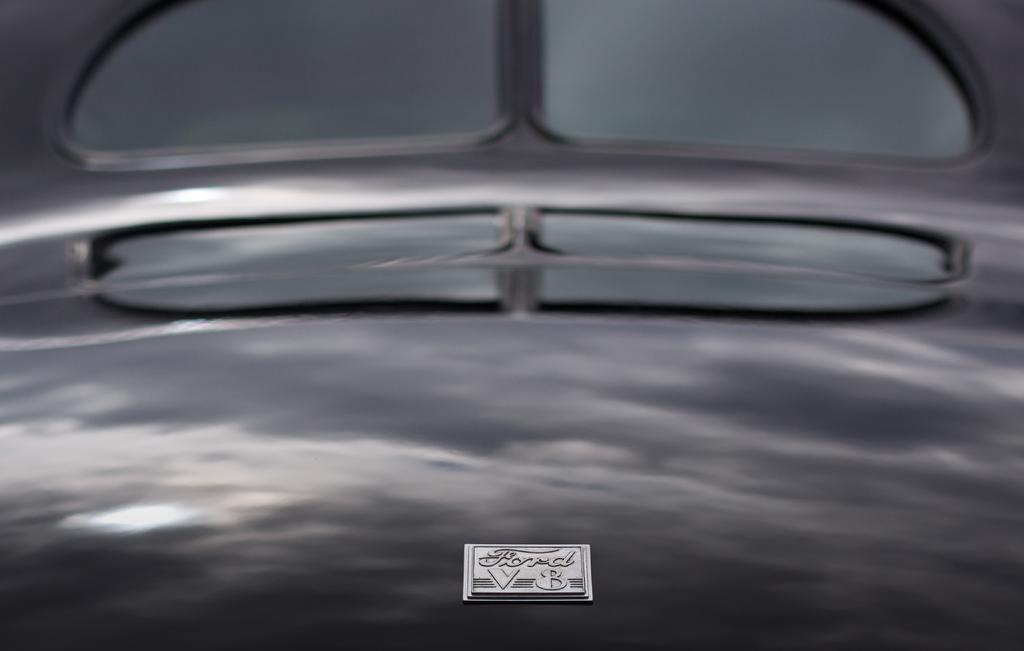What is the main subject in the image? There is a vehicle in the image. What can be seen on the surface of the vehicle? The reflection of clouds and the sky is visible on the vehicle. Can you see the reflection of a river on the vehicle in the image? There is no river present in the image, so its reflection cannot be seen on the vehicle. 